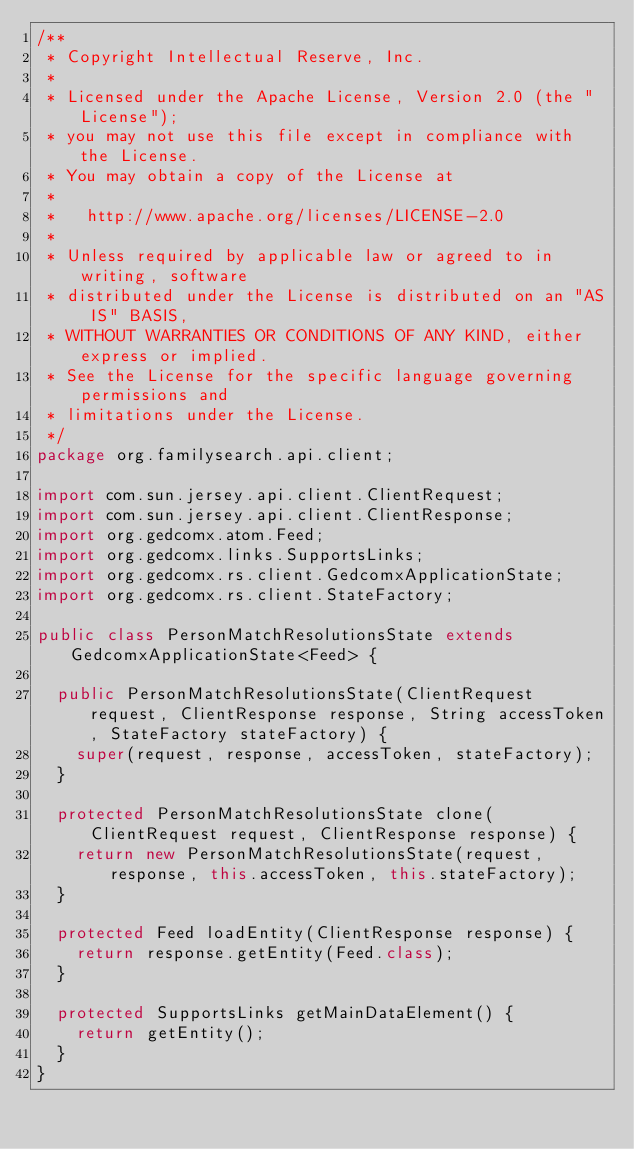Convert code to text. <code><loc_0><loc_0><loc_500><loc_500><_Java_>/**
 * Copyright Intellectual Reserve, Inc.
 *
 * Licensed under the Apache License, Version 2.0 (the "License");
 * you may not use this file except in compliance with the License.
 * You may obtain a copy of the License at
 *
 *   http://www.apache.org/licenses/LICENSE-2.0
 *
 * Unless required by applicable law or agreed to in writing, software
 * distributed under the License is distributed on an "AS IS" BASIS,
 * WITHOUT WARRANTIES OR CONDITIONS OF ANY KIND, either express or implied.
 * See the License for the specific language governing permissions and
 * limitations under the License.
 */
package org.familysearch.api.client;

import com.sun.jersey.api.client.ClientRequest;
import com.sun.jersey.api.client.ClientResponse;
import org.gedcomx.atom.Feed;
import org.gedcomx.links.SupportsLinks;
import org.gedcomx.rs.client.GedcomxApplicationState;
import org.gedcomx.rs.client.StateFactory;

public class PersonMatchResolutionsState extends GedcomxApplicationState<Feed> {

  public PersonMatchResolutionsState(ClientRequest request, ClientResponse response, String accessToken, StateFactory stateFactory) {
    super(request, response, accessToken, stateFactory);
  }

  protected PersonMatchResolutionsState clone(ClientRequest request, ClientResponse response) {
    return new PersonMatchResolutionsState(request, response, this.accessToken, this.stateFactory);
  }

  protected Feed loadEntity(ClientResponse response) {
    return response.getEntity(Feed.class);
  }

  protected SupportsLinks getMainDataElement() {
    return getEntity();
  }
}
</code> 